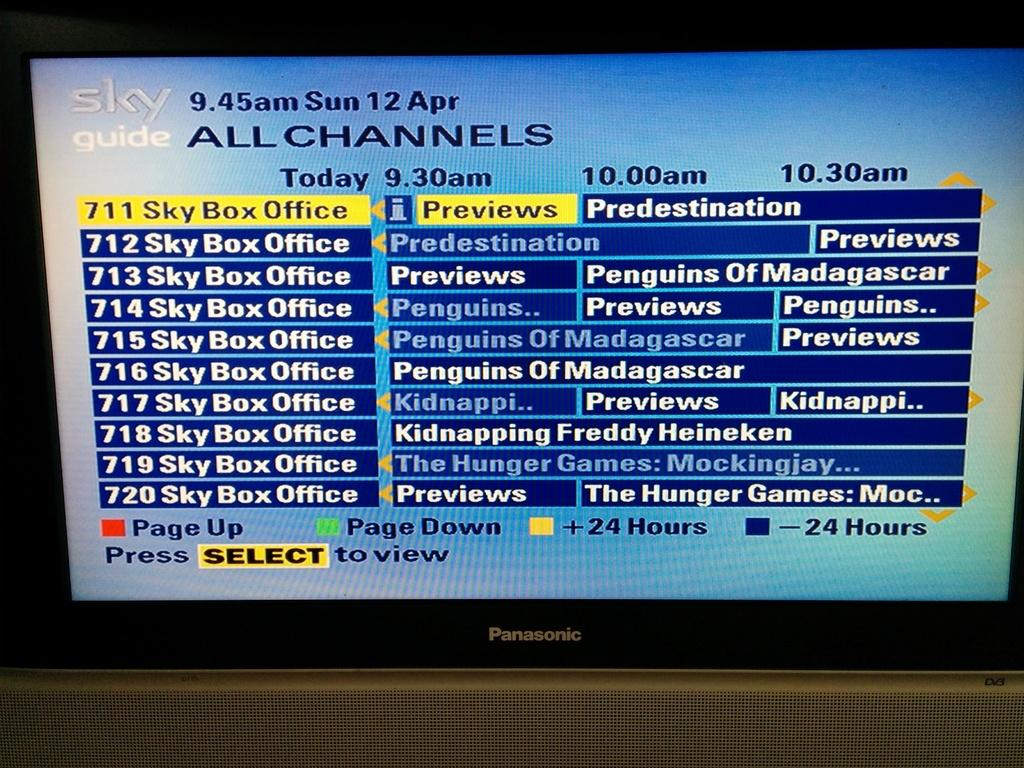Provide a one-sentence caption for the provided image. A Sky Guide menu lists a collection of movies like The Hunger Games, Predestination and Penguins of Madagascar. 